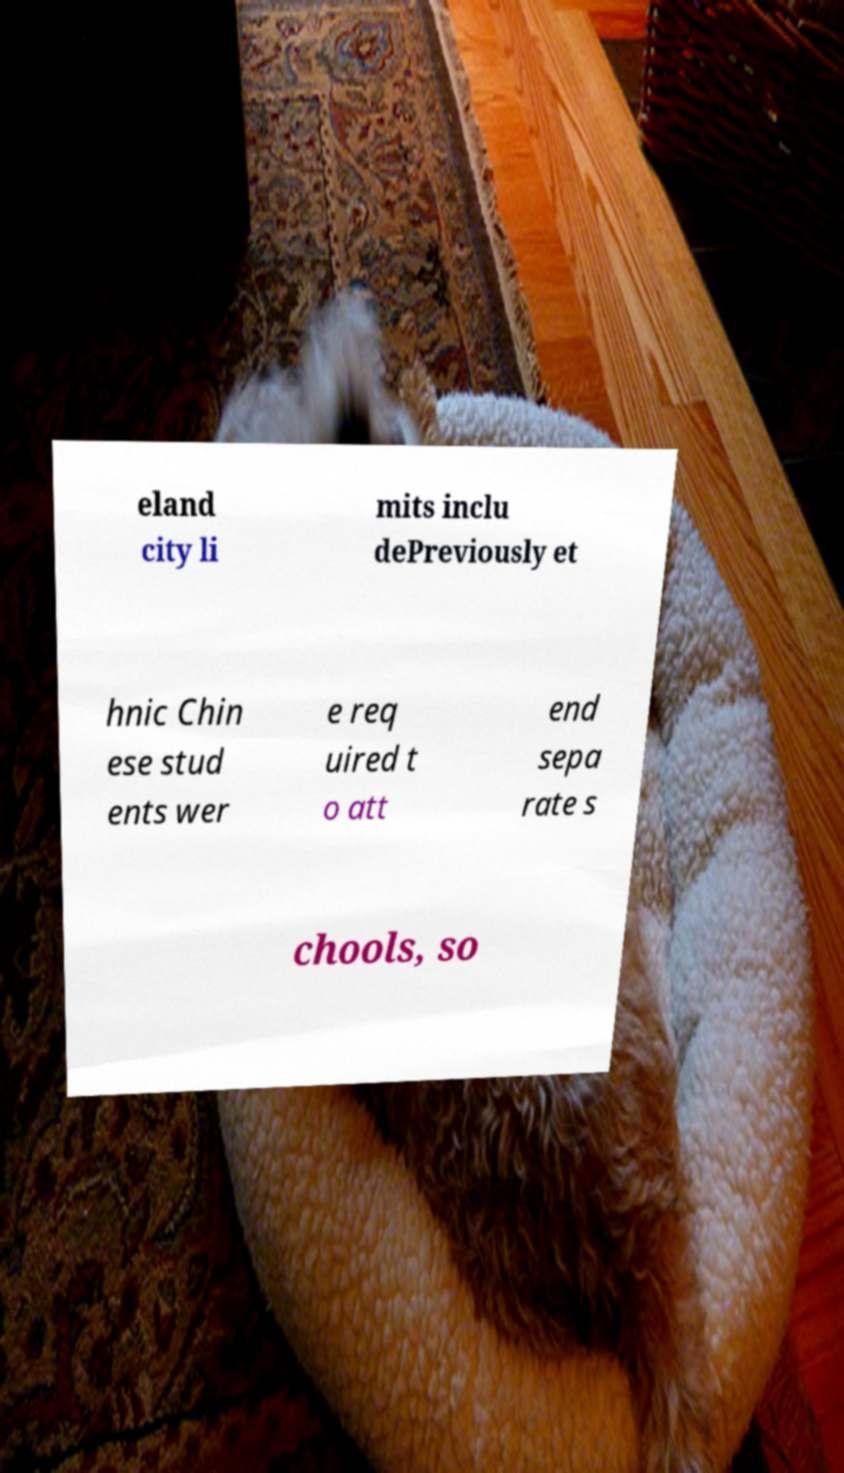Please identify and transcribe the text found in this image. eland city li mits inclu dePreviously et hnic Chin ese stud ents wer e req uired t o att end sepa rate s chools, so 